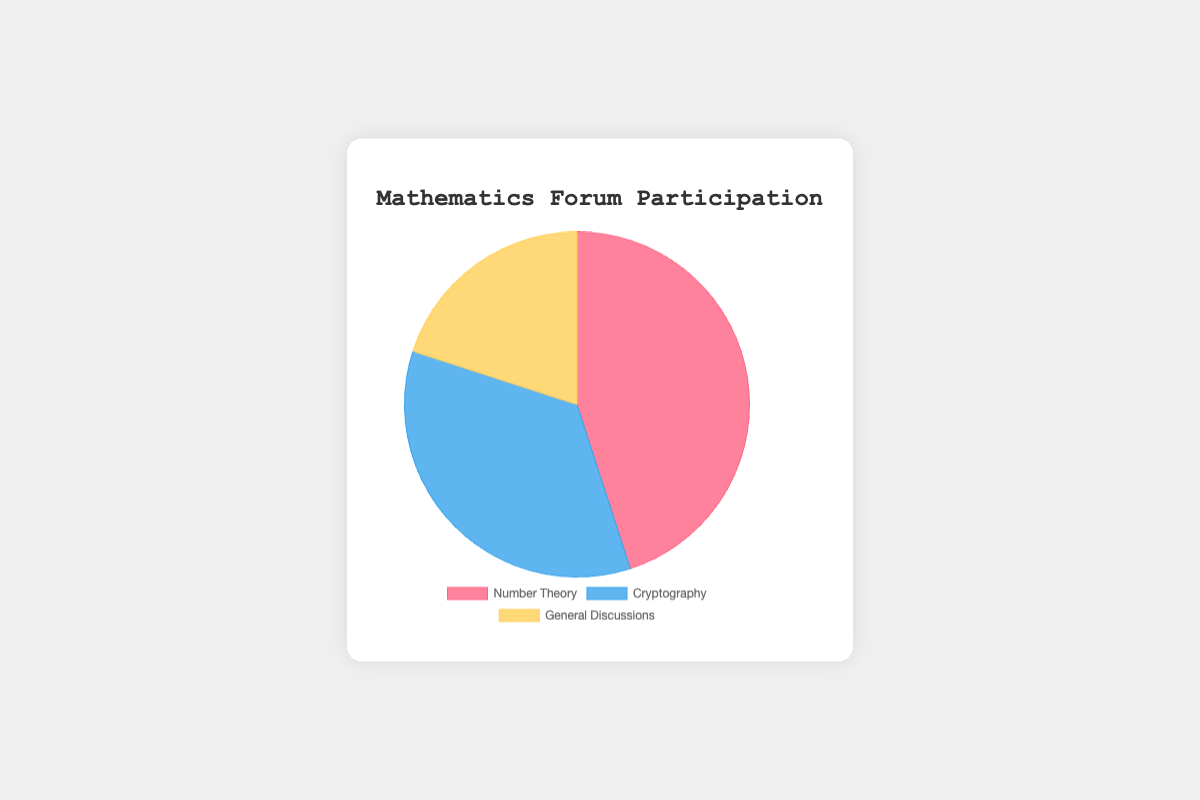What is the total participation percentage of both the Number Theory and General Discussions sections? The percentage for Number Theory is 45% and for General Discussions, it is 20%. Adding these two gives 45% + 20% = 65%.
Answer: 65% Which section has the highest participation percentage? By observing the chart, we see that the section with the highest participation is Number Theory with 45%.
Answer: Number Theory How much more participation does the Cryptography section have compared to General Discussions? The participation of the Cryptography section is 35% and General Discussions is 20%. The difference is 35% - 20% = 15%.
Answer: 15% What is the difference in participation percentage between the section with the highest participation and the section with the lowest participation? The highest participation is in Number Theory with 45%, and the lowest is in General Discussions with 20%. The difference is 45% - 20% = 25%.
Answer: 25% Which section has the smallest participation percentage and what is that percentage? From the chart, General Discussions has the smallest participation percentage, which is 20%.
Answer: General Discussions, 20% What is the average participation percentage across all sections? The percentages are 45% for Number Theory, 35% for Cryptography, and 20% for General Discussions. The sum is 45% + 35% + 20% = 100%, and the average is 100% / 3 ≈ 33.33%.
Answer: Approximately 33.33% Which section is represented by the blue color, and what is its participation percentage? The chart indicates that the blue color represents the Cryptography section, which has a participation percentage of 35%.
Answer: Cryptography, 35% How does the participation in Number Theory compare to the combined participation in Cryptography and General Discussions? The participation in Number Theory is 45%. The combined participation in Cryptography and General Discussions is 35% + 20% = 55%. Therefore, Number Theory has 10% less participation than the combined sections.
Answer: Number Theory has 10% less Is the participation in Number Theory more than double the participation in General Discussions? The participation in Number Theory is 45%, and in General Discussions, it is 20%. Double the participation in General Discussions would be 20% * 2 = 40%. Since 45% > 40%, the participation in Number Theory is indeed more than double that of General Discussions.
Answer: Yes 